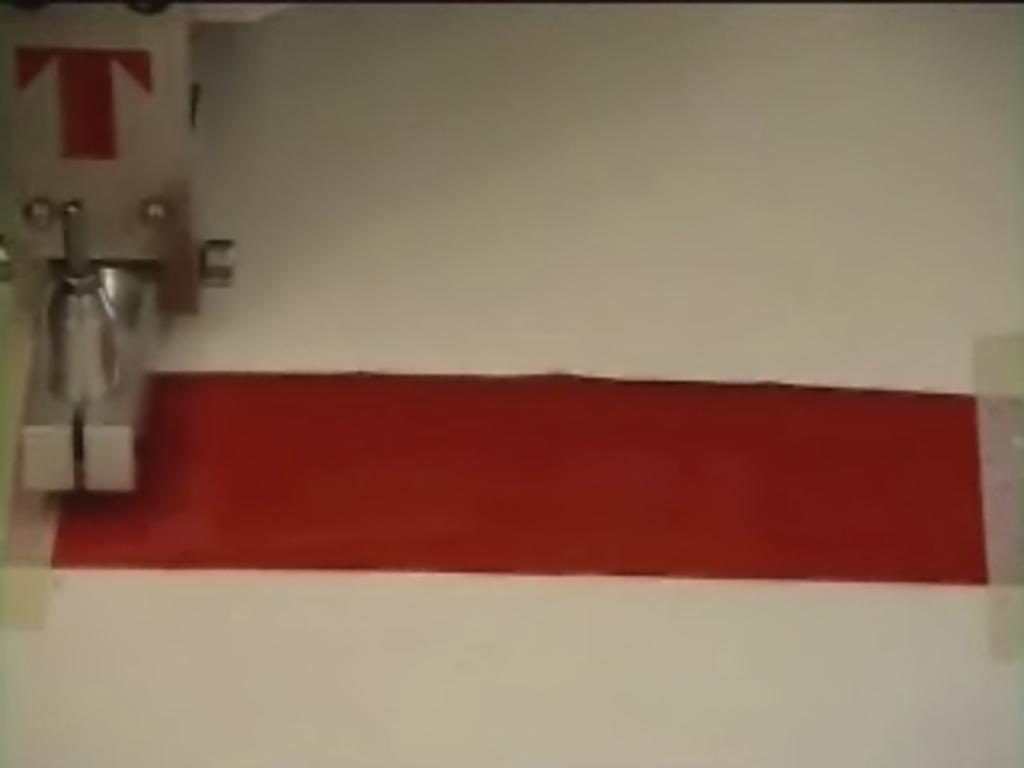What is the main object on the left side of the image? There is a machine on the left side of the image. What color is the cloth in the image? The cloth in the image is red. Where is the red cloth placed in the image? The red cloth is on a white surface in the image. What type of club is being used in the competition shown in the image? There is no club or competition present in the image; it features a machine and a red cloth on a white surface. Can you describe the sidewalk in the image? There is no sidewalk present in the image. 